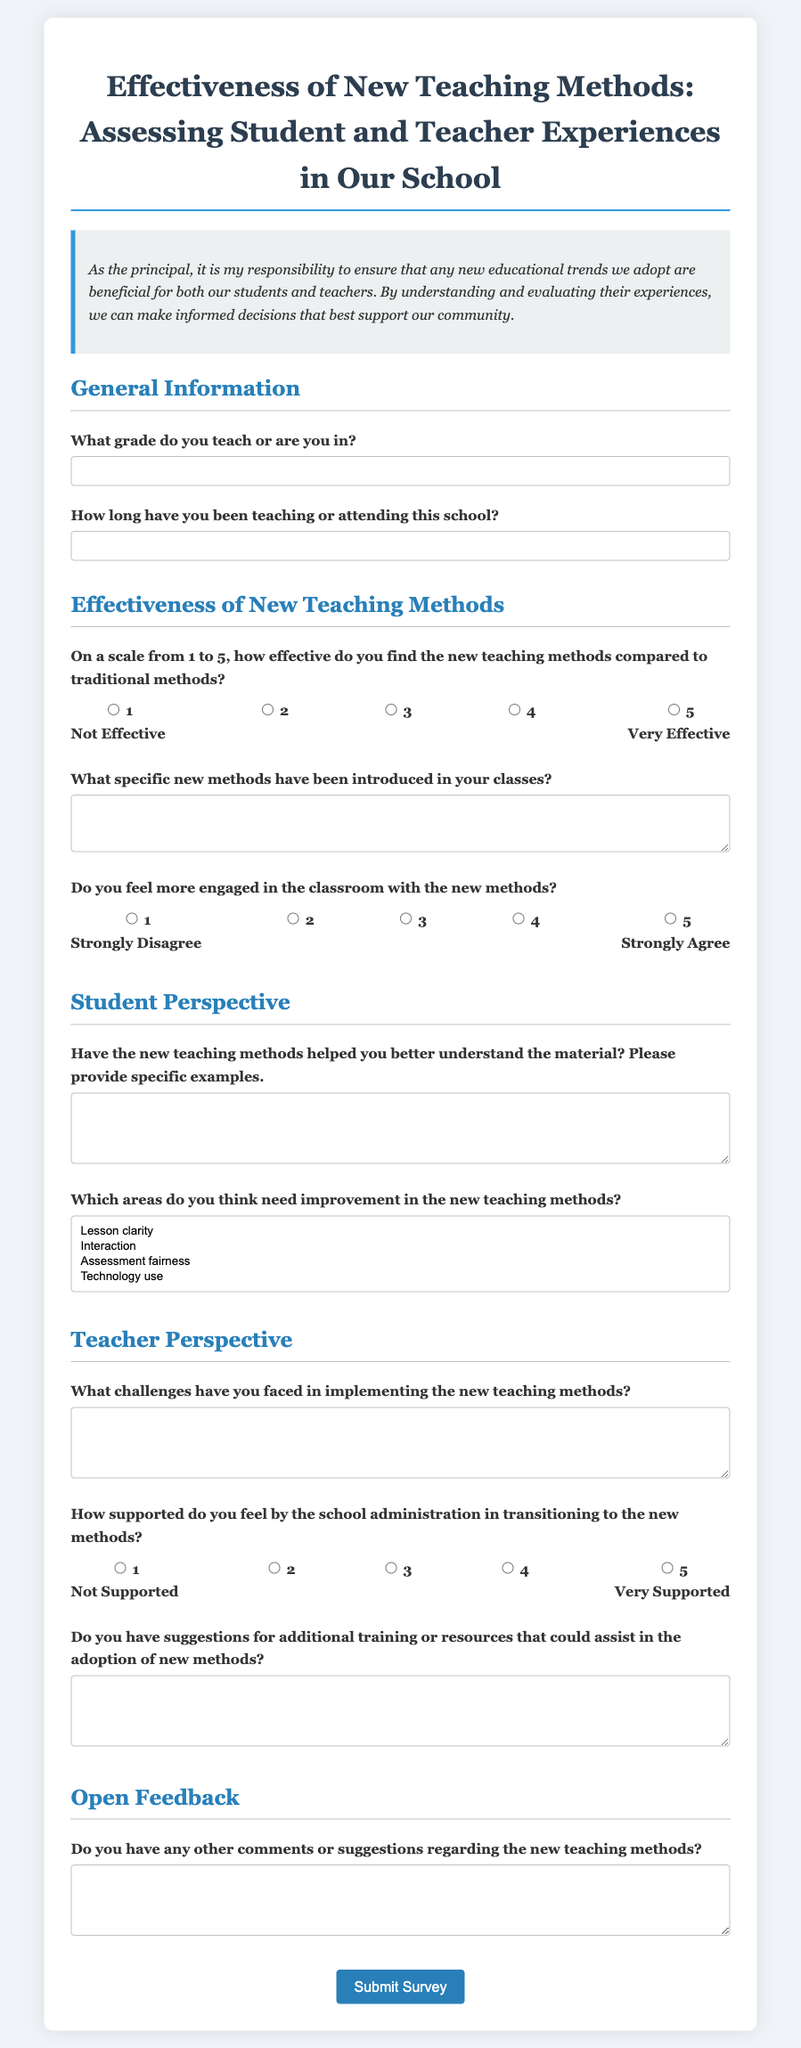What is the title of the survey? The title is located at the top of the document, summarizing the purpose of the survey.
Answer: Effectiveness of New Teaching Methods: Assessing Student and Teacher Experiences in Our School What is one of the sections included in the survey? The document has various sections that categorize the questions, such as General Information and Teacher Perspective.
Answer: General Information What type of feedback does the survey seek in the last section? The last section of the survey is designed to gather overall impressions and suggestions for improvement.
Answer: Open Feedback How long has the respondent been teaching or attending this school? This information is required in the General Information section of the survey.
Answer: Input as text (variable answer) On a scale from 1 to 5, what does a response of 5 indicate regarding the effectiveness of new teaching methods? The survey provides a rating scale, and the highest rating indicates a very positive assessment of the new methods.
Answer: Very Effective What is one area of improvement that respondents can select concerning new teaching methods? The options provided in the survey allow respondents to specify areas needing enhancement, demonstrating the focus on constructive feedback.
Answer: Lesson clarity What type of support question is included for teachers in the survey? This question assesses the level of administrative support during the transition to new teaching methods, reflecting on teacher experiences.
Answer: How supported do you feel by the school administration in transitioning to the new methods? What specific format does the respondent need to use when describing the new methods? The survey allows for open-ended responses, asking for a description of specific new methods implemented in the classes.
Answer: Input as text (variable answer) 